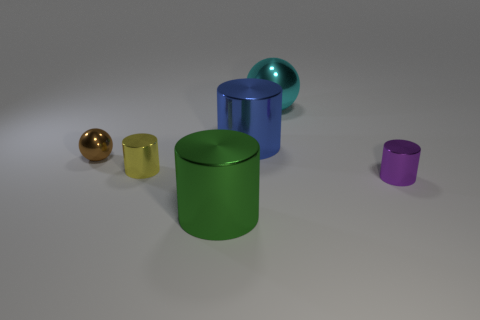Are there more brown metal balls that are behind the small brown sphere than big cyan spheres that are on the right side of the cyan ball?
Provide a succinct answer. No. Is the material of the blue object the same as the tiny cylinder that is to the right of the green shiny object?
Give a very brief answer. Yes. Is there any other thing that is the same shape as the purple thing?
Offer a very short reply. Yes. What color is the shiny cylinder that is left of the cyan metallic sphere and in front of the yellow thing?
Offer a terse response. Green. There is a big shiny thing that is in front of the yellow metal object; what is its shape?
Ensure brevity in your answer.  Cylinder. What is the size of the cylinder in front of the metallic thing that is to the right of the sphere right of the green metallic thing?
Provide a succinct answer. Large. How many tiny brown things are behind the tiny cylinder right of the blue cylinder?
Offer a terse response. 1. How big is the shiny object that is both on the left side of the large green cylinder and right of the brown object?
Make the answer very short. Small. How many matte objects are either red balls or large blue things?
Make the answer very short. 0. What material is the purple object?
Offer a very short reply. Metal. 